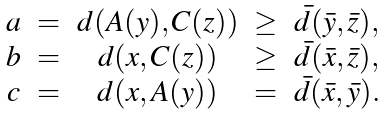<formula> <loc_0><loc_0><loc_500><loc_500>\begin{array} { c c c c c } a & = & d ( A ( y ) , C ( z ) ) & \geq & \bar { d } ( \bar { y } , \bar { z } ) , \\ b & = & d ( x , C ( z ) ) & \geq & \bar { d } ( \bar { x } , \bar { z } ) , \\ c & = & d ( x , A ( y ) ) & = & \bar { d } ( \bar { x } , \bar { y } ) . \\ \end{array}</formula> 